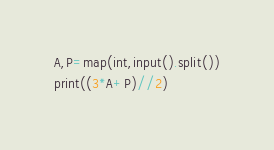<code> <loc_0><loc_0><loc_500><loc_500><_Python_>A,P=map(int,input().split())
print((3*A+P)//2)</code> 